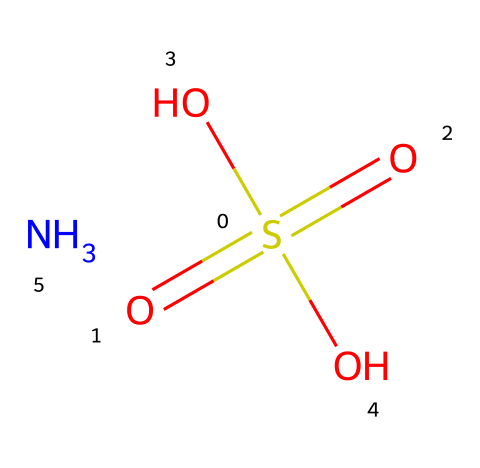How many oxygen atoms are present in this compound? The SMILES representation shows four oxygen atoms represented by "(=O)(=O)(O)O". Count the number of "O" present, which totals to four.
Answer: four What is the oxidation state of sulfur in this compound? The sulfur atom is connected to four oxygen atoms with two double bonds and two single bonds. In this configuration, the oxidation state of sulfur is +6, as it has lost six electrons to form bonds with four oxygen atoms.
Answer: +6 What type of compound is represented by this SMILES notation? The presence of sulfur and oxygen, along with the nitrogen atom in the structure, indicates that this compound is a sulfur-based fertilizer, specifically an amine-sulfonic acid.
Answer: sulfur-based fertilizer How many hydrogen atoms are in this molecule? Analyzing the SMILES notation, there is one nitrogen atom, which indicates one hydrogen atom bonded to it (as indicated by ".N"). There are no additional hydrogen atoms directly indicated by the structure, leading to a total of one.
Answer: one What is the role of sulfur in fertilizers on football pitches? In fertilizers, sulfur plays a crucial role by aiding in chlorophyll formation and enhancing nitrogen uptake, which are essential for plant health and growth, particularly in turf management for football pitches.
Answer: enhances plant health 